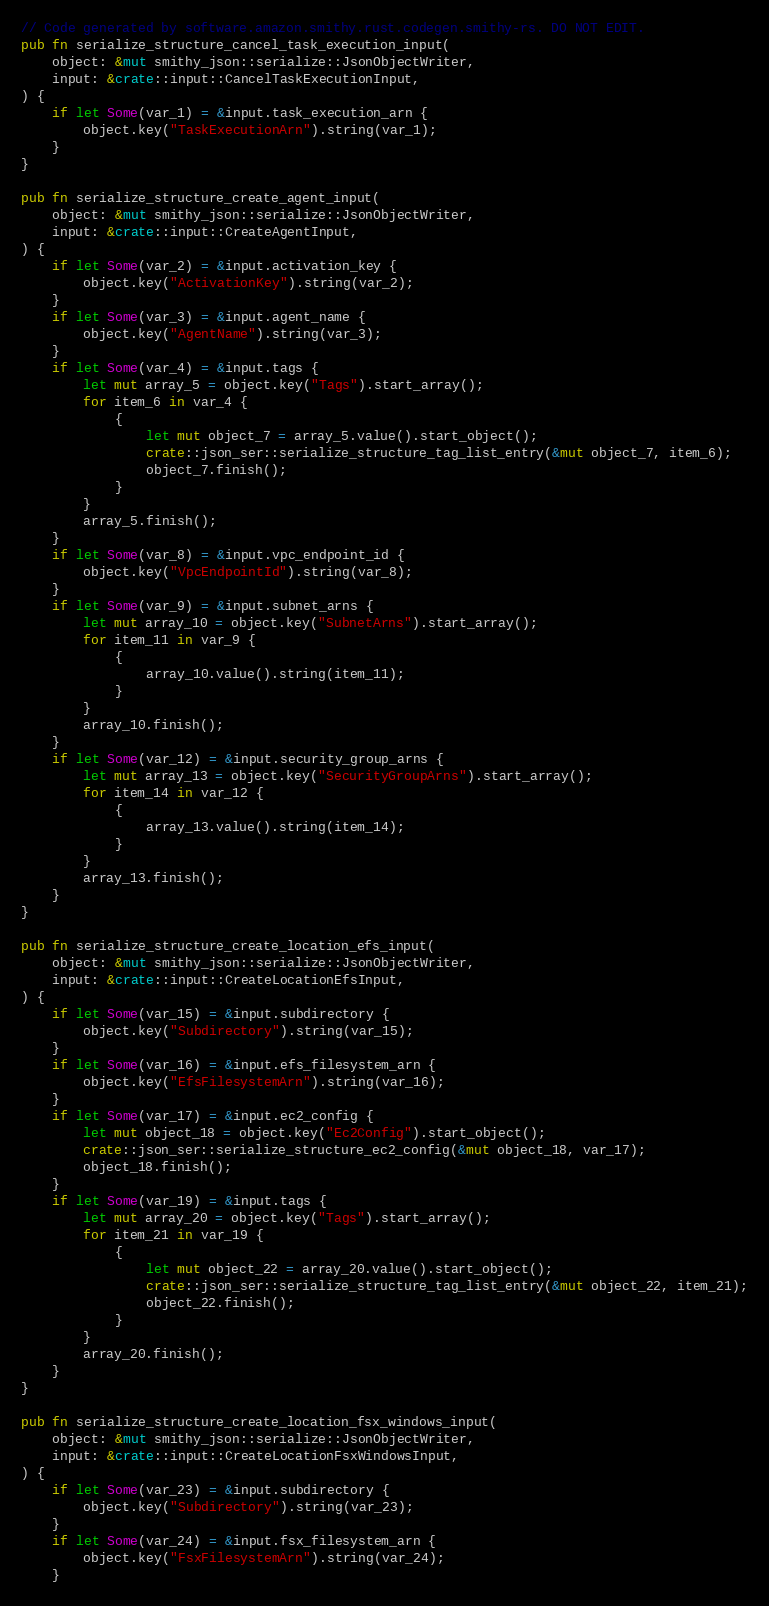<code> <loc_0><loc_0><loc_500><loc_500><_Rust_>// Code generated by software.amazon.smithy.rust.codegen.smithy-rs. DO NOT EDIT.
pub fn serialize_structure_cancel_task_execution_input(
    object: &mut smithy_json::serialize::JsonObjectWriter,
    input: &crate::input::CancelTaskExecutionInput,
) {
    if let Some(var_1) = &input.task_execution_arn {
        object.key("TaskExecutionArn").string(var_1);
    }
}

pub fn serialize_structure_create_agent_input(
    object: &mut smithy_json::serialize::JsonObjectWriter,
    input: &crate::input::CreateAgentInput,
) {
    if let Some(var_2) = &input.activation_key {
        object.key("ActivationKey").string(var_2);
    }
    if let Some(var_3) = &input.agent_name {
        object.key("AgentName").string(var_3);
    }
    if let Some(var_4) = &input.tags {
        let mut array_5 = object.key("Tags").start_array();
        for item_6 in var_4 {
            {
                let mut object_7 = array_5.value().start_object();
                crate::json_ser::serialize_structure_tag_list_entry(&mut object_7, item_6);
                object_7.finish();
            }
        }
        array_5.finish();
    }
    if let Some(var_8) = &input.vpc_endpoint_id {
        object.key("VpcEndpointId").string(var_8);
    }
    if let Some(var_9) = &input.subnet_arns {
        let mut array_10 = object.key("SubnetArns").start_array();
        for item_11 in var_9 {
            {
                array_10.value().string(item_11);
            }
        }
        array_10.finish();
    }
    if let Some(var_12) = &input.security_group_arns {
        let mut array_13 = object.key("SecurityGroupArns").start_array();
        for item_14 in var_12 {
            {
                array_13.value().string(item_14);
            }
        }
        array_13.finish();
    }
}

pub fn serialize_structure_create_location_efs_input(
    object: &mut smithy_json::serialize::JsonObjectWriter,
    input: &crate::input::CreateLocationEfsInput,
) {
    if let Some(var_15) = &input.subdirectory {
        object.key("Subdirectory").string(var_15);
    }
    if let Some(var_16) = &input.efs_filesystem_arn {
        object.key("EfsFilesystemArn").string(var_16);
    }
    if let Some(var_17) = &input.ec2_config {
        let mut object_18 = object.key("Ec2Config").start_object();
        crate::json_ser::serialize_structure_ec2_config(&mut object_18, var_17);
        object_18.finish();
    }
    if let Some(var_19) = &input.tags {
        let mut array_20 = object.key("Tags").start_array();
        for item_21 in var_19 {
            {
                let mut object_22 = array_20.value().start_object();
                crate::json_ser::serialize_structure_tag_list_entry(&mut object_22, item_21);
                object_22.finish();
            }
        }
        array_20.finish();
    }
}

pub fn serialize_structure_create_location_fsx_windows_input(
    object: &mut smithy_json::serialize::JsonObjectWriter,
    input: &crate::input::CreateLocationFsxWindowsInput,
) {
    if let Some(var_23) = &input.subdirectory {
        object.key("Subdirectory").string(var_23);
    }
    if let Some(var_24) = &input.fsx_filesystem_arn {
        object.key("FsxFilesystemArn").string(var_24);
    }</code> 